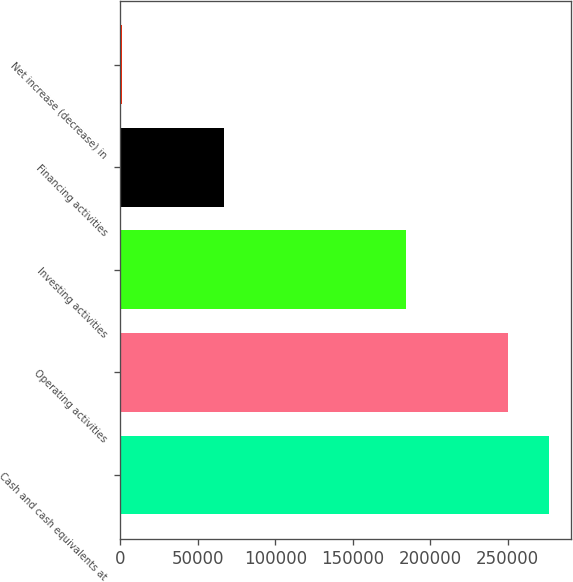Convert chart to OTSL. <chart><loc_0><loc_0><loc_500><loc_500><bar_chart><fcel>Cash and cash equivalents at<fcel>Operating activities<fcel>Investing activities<fcel>Financing activities<fcel>Net increase (decrease) in<nl><fcel>276782<fcel>250405<fcel>184588<fcel>66527<fcel>710<nl></chart> 